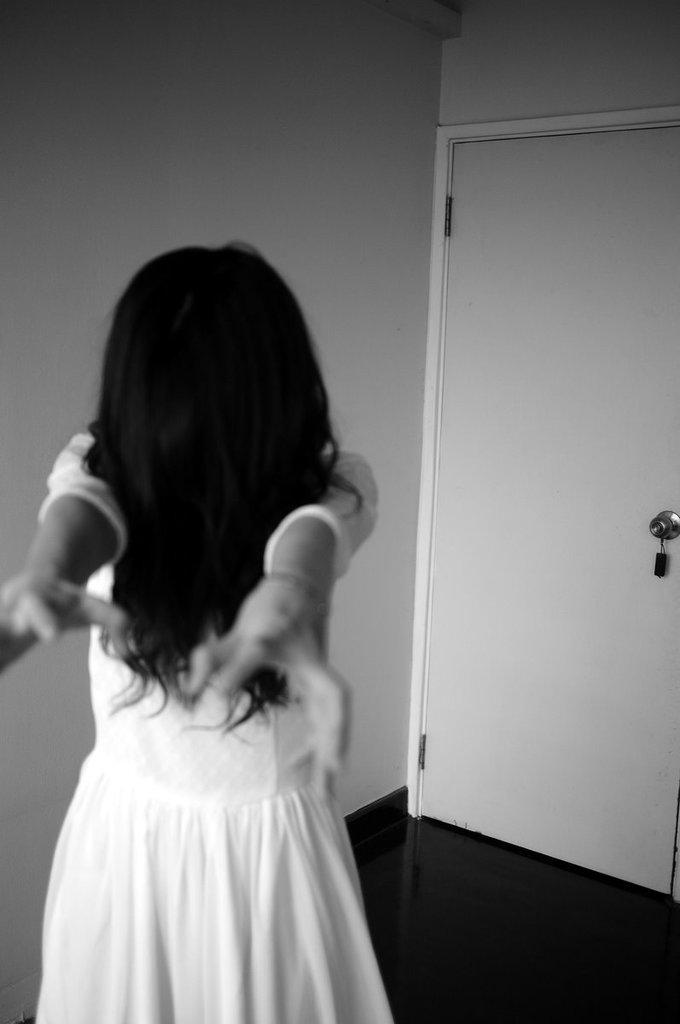Who is present in the image? There is a woman in the image. What is the woman wearing? The woman is wearing a white dress. What can be seen in the background of the image? There is a wall and a door in the image. How many dogs are visible in the image? There are no dogs present in the image. What type of grain is being harvested in the background of the image? There is no grain or harvesting activity present in the image. 